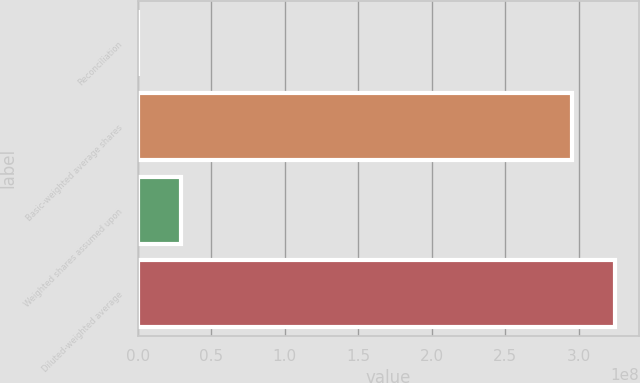<chart> <loc_0><loc_0><loc_500><loc_500><bar_chart><fcel>Reconciliation<fcel>Basic-weighted average shares<fcel>Weighted shares assumed upon<fcel>Diluted-weighted average<nl><fcel>2011<fcel>2.95054e+08<fcel>2.95887e+07<fcel>3.2464e+08<nl></chart> 